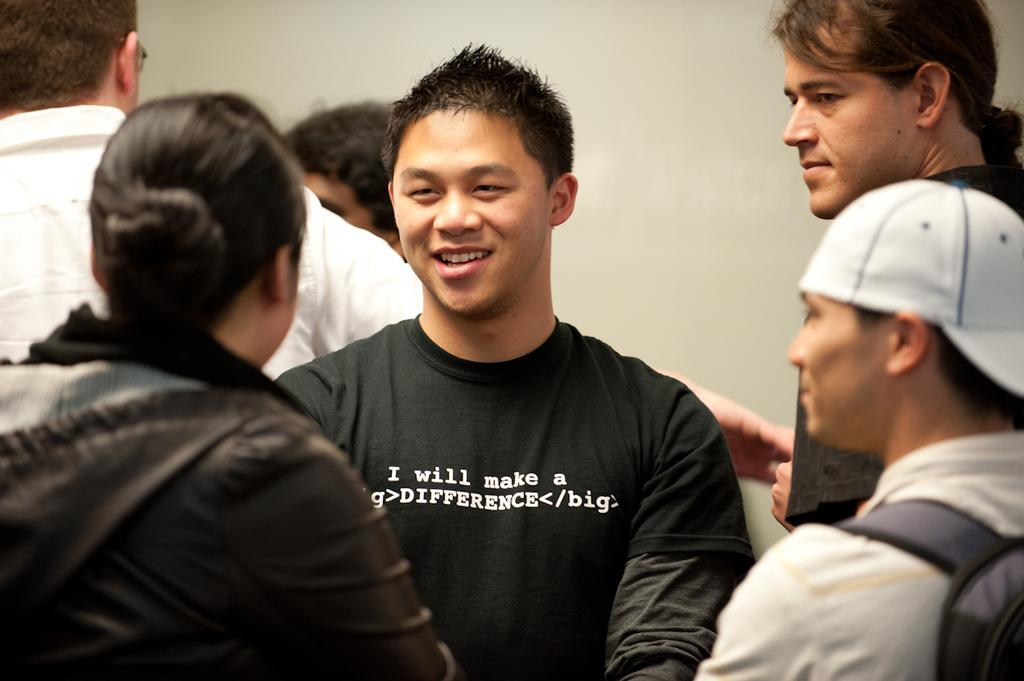What is the man in the image doing? The man is standing and smiling in the image. How many people are present in the image? There is a group of people standing in the image. What can be seen in the background of the image? There is a wall in the background of the image. What is the color of the wall? The wall is white in color. What type of fork can be seen in the man's hand in the image? There is no fork present in the image; the man is not holding any object. 